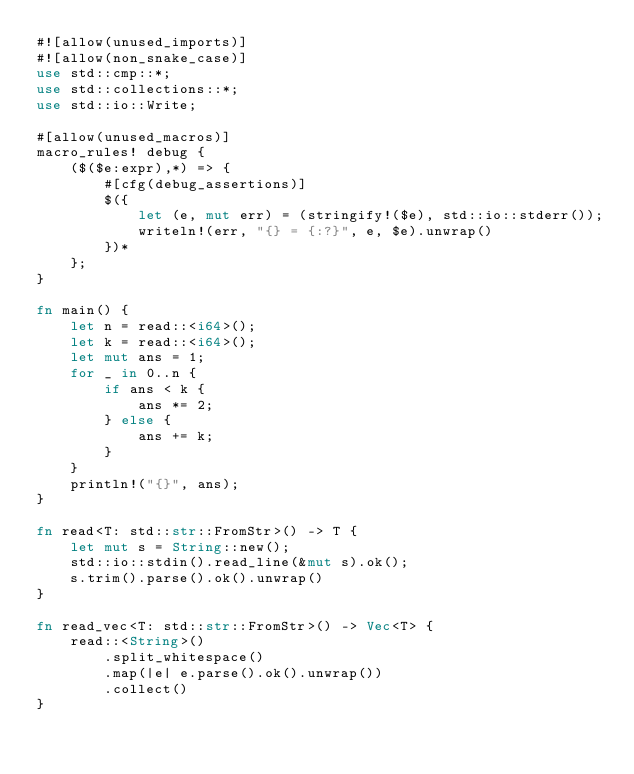<code> <loc_0><loc_0><loc_500><loc_500><_Rust_>#![allow(unused_imports)]
#![allow(non_snake_case)]
use std::cmp::*;
use std::collections::*;
use std::io::Write;

#[allow(unused_macros)]
macro_rules! debug {
    ($($e:expr),*) => {
        #[cfg(debug_assertions)]
        $({
            let (e, mut err) = (stringify!($e), std::io::stderr());
            writeln!(err, "{} = {:?}", e, $e).unwrap()
        })*
    };
}

fn main() {
    let n = read::<i64>();
    let k = read::<i64>();
    let mut ans = 1;
    for _ in 0..n {
        if ans < k {
            ans *= 2;
        } else {
            ans += k;
        }
    }
    println!("{}", ans);
}

fn read<T: std::str::FromStr>() -> T {
    let mut s = String::new();
    std::io::stdin().read_line(&mut s).ok();
    s.trim().parse().ok().unwrap()
}

fn read_vec<T: std::str::FromStr>() -> Vec<T> {
    read::<String>()
        .split_whitespace()
        .map(|e| e.parse().ok().unwrap())
        .collect()
}
</code> 